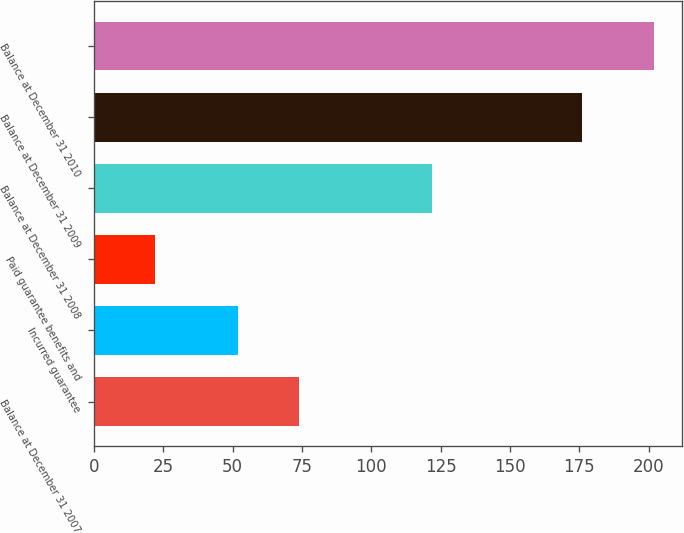<chart> <loc_0><loc_0><loc_500><loc_500><bar_chart><fcel>Balance at December 31 2007<fcel>Incurred guarantee<fcel>Paid guarantee benefits and<fcel>Balance at December 31 2008<fcel>Balance at December 31 2009<fcel>Balance at December 31 2010<nl><fcel>74<fcel>52<fcel>22<fcel>122<fcel>176<fcel>202<nl></chart> 